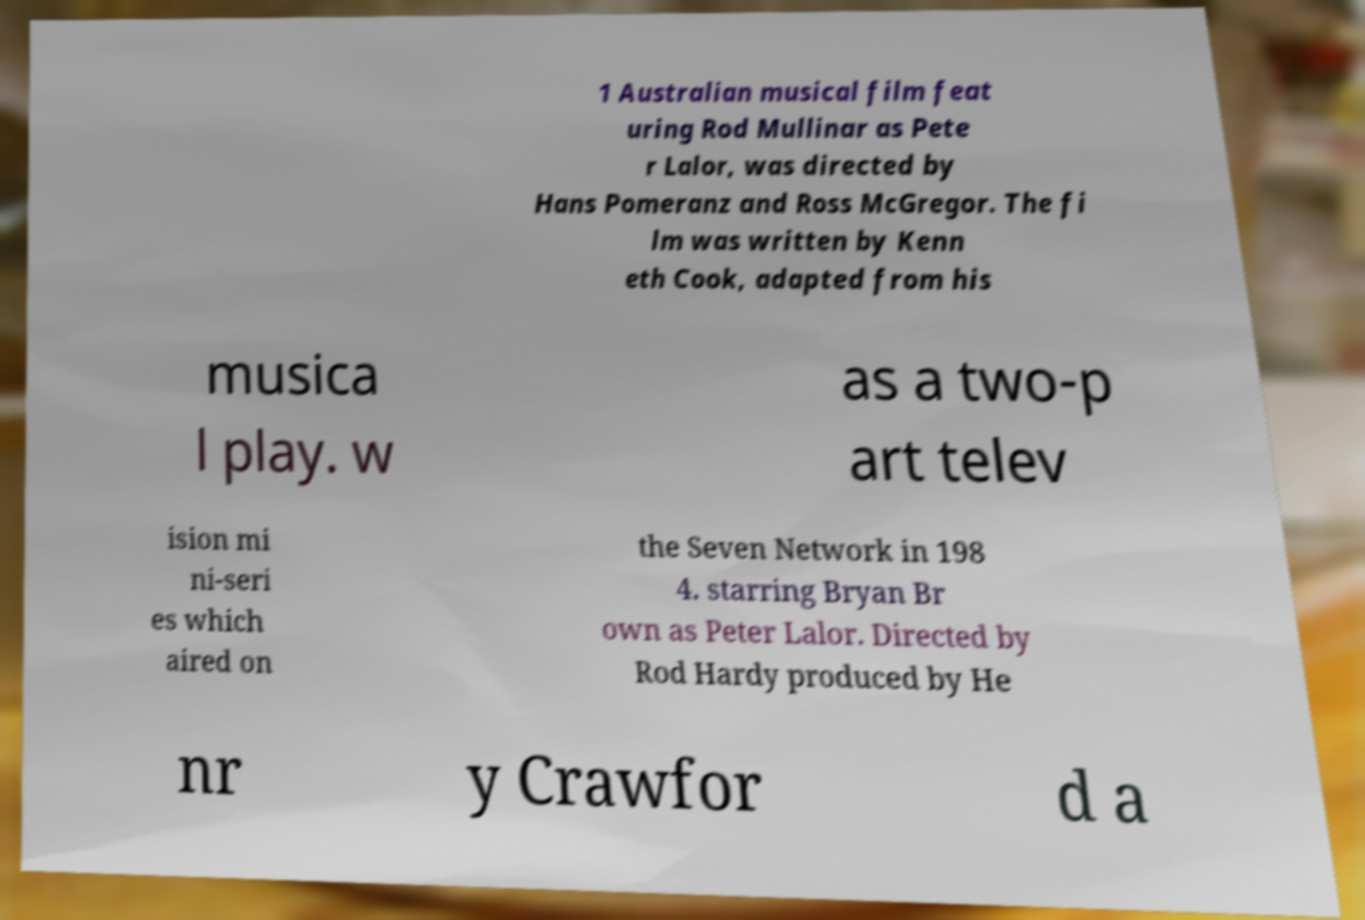Please identify and transcribe the text found in this image. 1 Australian musical film feat uring Rod Mullinar as Pete r Lalor, was directed by Hans Pomeranz and Ross McGregor. The fi lm was written by Kenn eth Cook, adapted from his musica l play. w as a two-p art telev ision mi ni-seri es which aired on the Seven Network in 198 4. starring Bryan Br own as Peter Lalor. Directed by Rod Hardy produced by He nr y Crawfor d a 